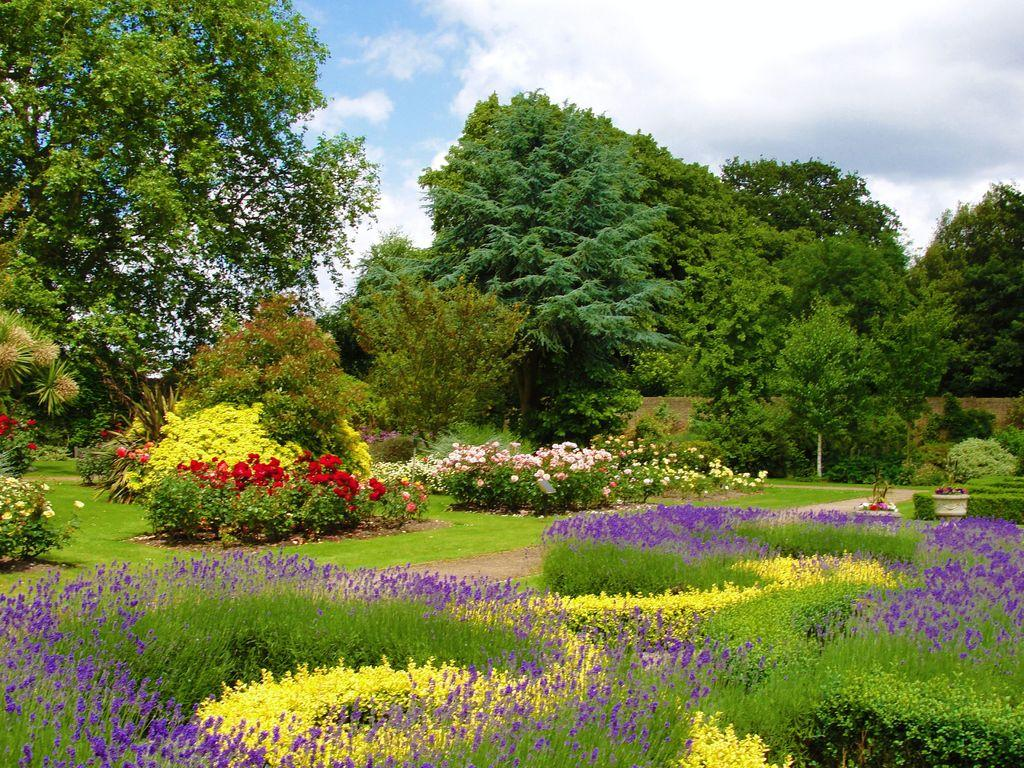What type of vegetation can be seen in the image? There is grass, flowers, plants, and trees visible in the image. What type of structure can be seen in the image? There is a wall visible in the image. What is visible in the sky in the image? The sky is visible in the image, and there are clouds visible. Can you see any thrill in the image? There is no indication of thrill in the image; it features natural elements such as grass, flowers, plants, trees, a wall, the sky, and clouds. Is there a wrench visible in the image? There is no wrench present in the image. 